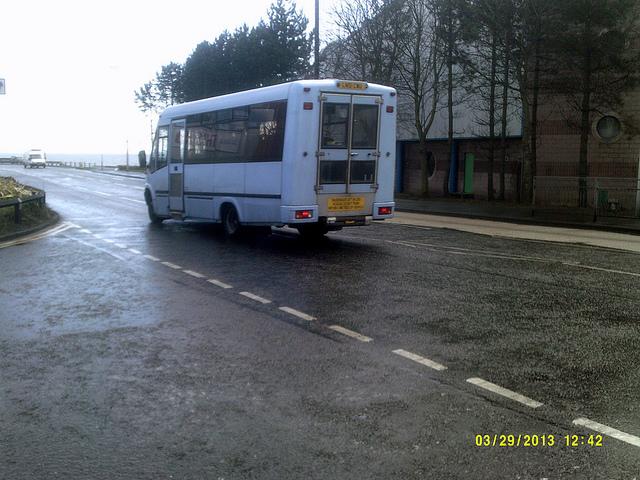Do the streets see, wet?
Keep it brief. Yes. Which side of the road is the vehicle traveling on?
Answer briefly. Left. Are the reverse lights on?
Be succinct. No. 